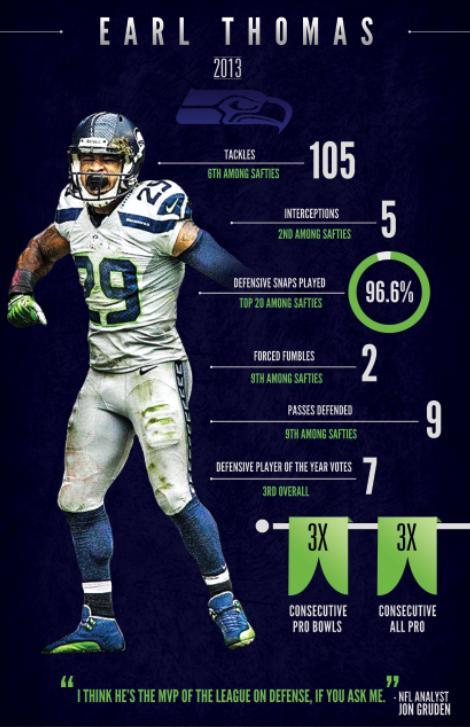Which team does Earl Thomas play for , Seattle Seahawks, Baltimore Ravens, or Philadelphia Eagles?
Answer the question with a short phrase. Seattle Seahawks 